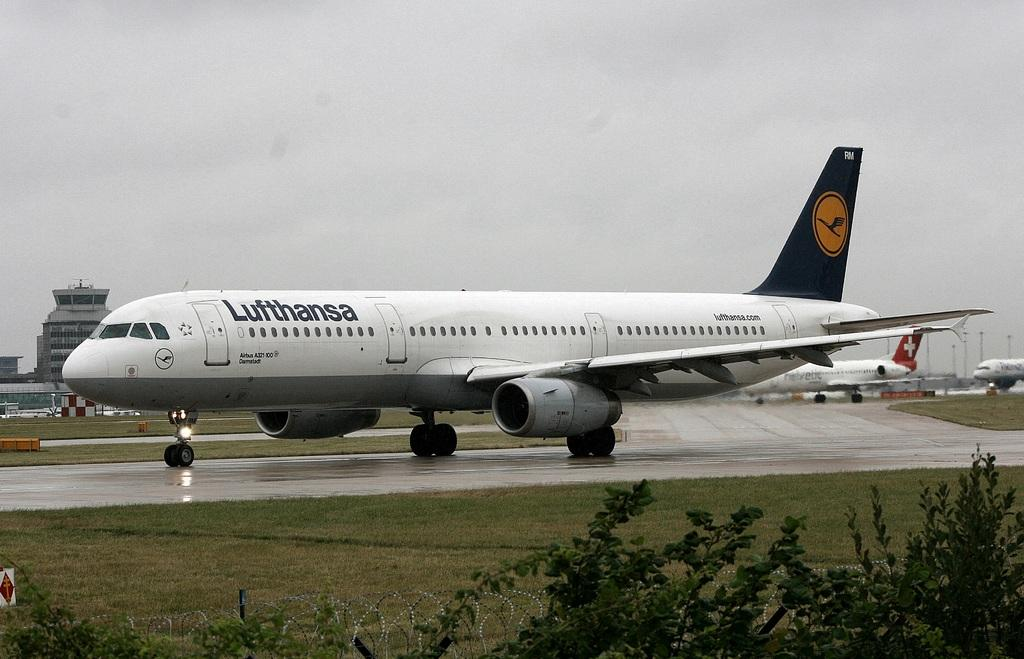<image>
Describe the image concisely. A Lufthansa plane is on the runway on an overcast day. 